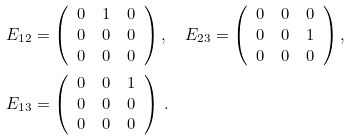Convert formula to latex. <formula><loc_0><loc_0><loc_500><loc_500>E _ { 1 2 } & = \left ( \begin{array} { c c c } 0 & 1 & 0 \\ 0 & 0 & 0 \\ 0 & 0 & 0 \end{array} \right ) , \quad E _ { 2 3 } = \left ( \begin{array} { c c c } 0 & 0 & 0 \\ 0 & 0 & 1 \\ 0 & 0 & 0 \end{array} \right ) , \quad \\ E _ { 1 3 } & = \left ( \begin{array} { c c c } 0 & 0 & 1 \\ 0 & 0 & 0 \\ 0 & 0 & 0 \end{array} \right ) \, .</formula> 